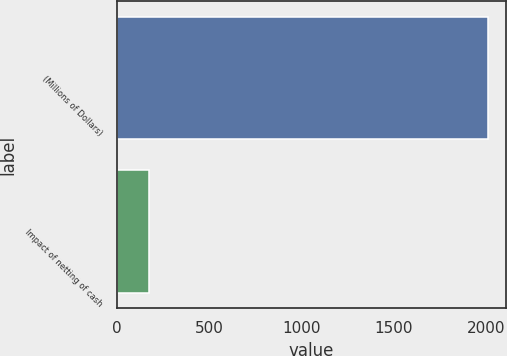Convert chart to OTSL. <chart><loc_0><loc_0><loc_500><loc_500><bar_chart><fcel>(Millions of Dollars)<fcel>Impact of netting of cash<nl><fcel>2010<fcel>176<nl></chart> 